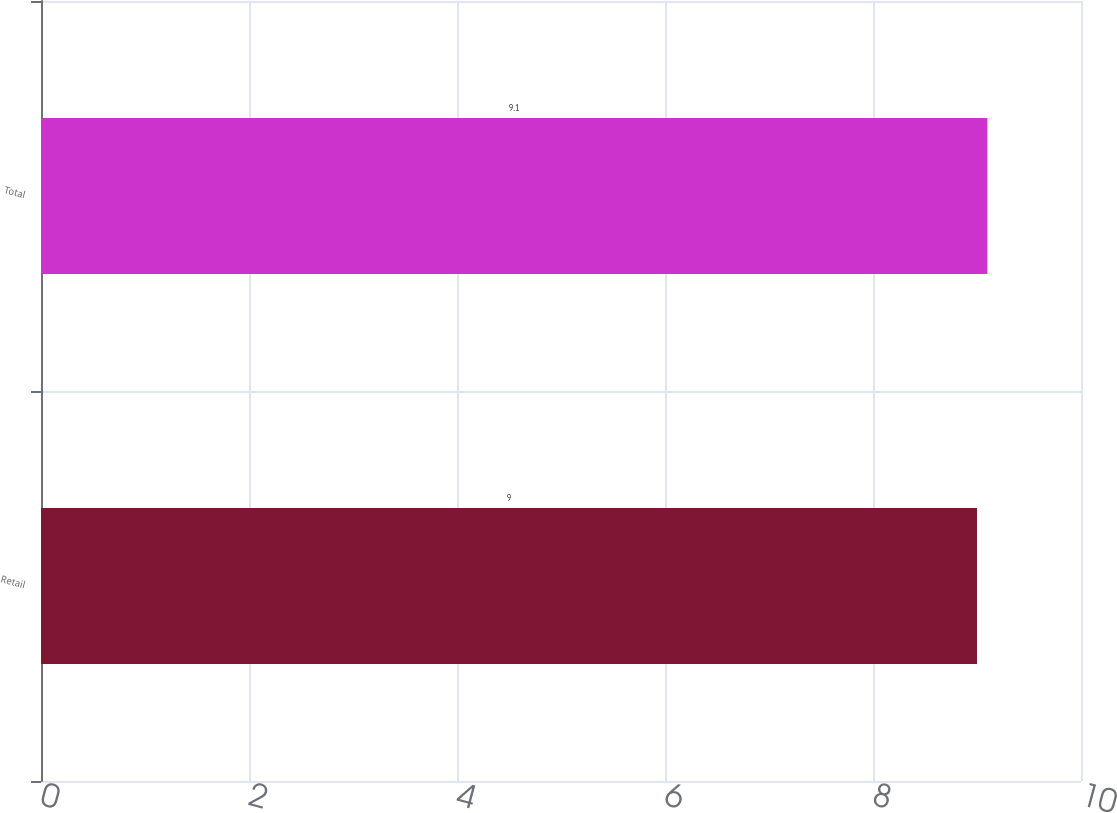Convert chart. <chart><loc_0><loc_0><loc_500><loc_500><bar_chart><fcel>Retail<fcel>Total<nl><fcel>9<fcel>9.1<nl></chart> 